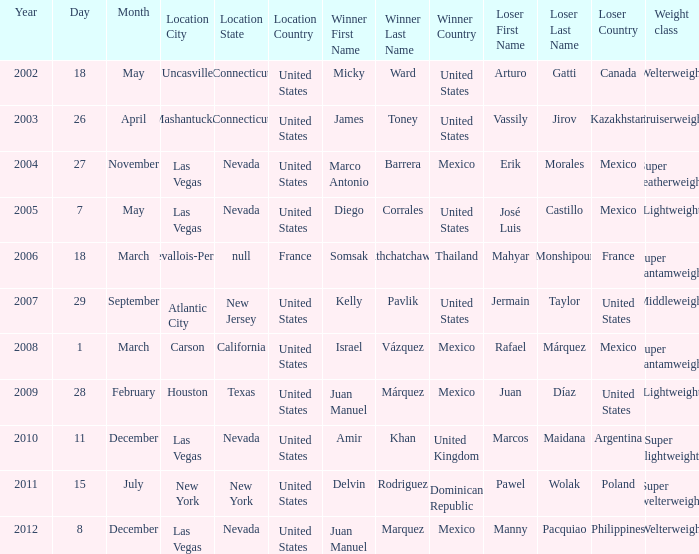How many years were lightweight class on february 28, 2009? 1.0. 